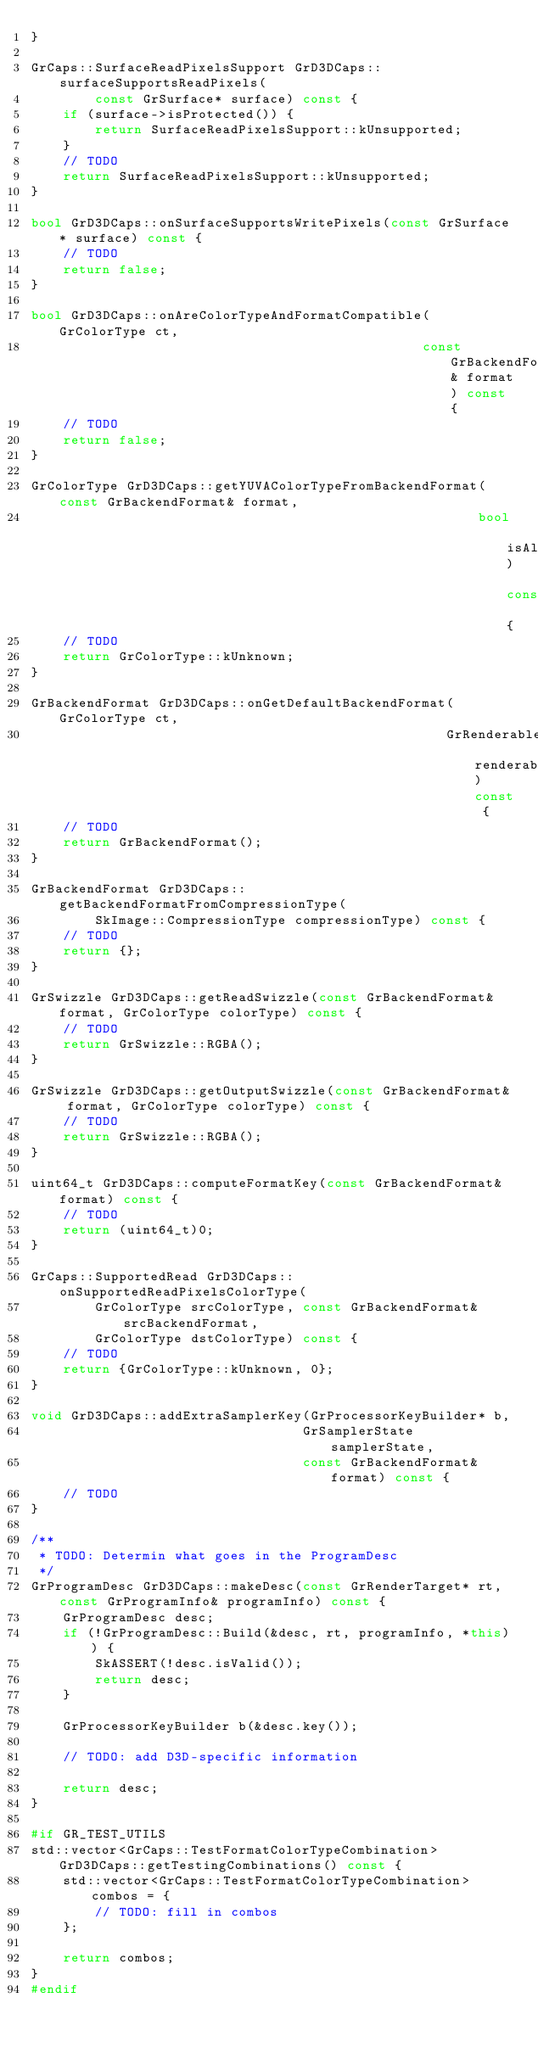Convert code to text. <code><loc_0><loc_0><loc_500><loc_500><_C++_>}

GrCaps::SurfaceReadPixelsSupport GrD3DCaps::surfaceSupportsReadPixels(
        const GrSurface* surface) const {
    if (surface->isProtected()) {
        return SurfaceReadPixelsSupport::kUnsupported;
    }
    // TODO
    return SurfaceReadPixelsSupport::kUnsupported;
}

bool GrD3DCaps::onSurfaceSupportsWritePixels(const GrSurface* surface) const {
    // TODO
    return false;
}

bool GrD3DCaps::onAreColorTypeAndFormatCompatible(GrColorType ct,
                                                 const GrBackendFormat& format) const {
    // TODO
    return false;
}

GrColorType GrD3DCaps::getYUVAColorTypeFromBackendFormat(const GrBackendFormat& format,
                                                        bool isAlphaChannel) const {
    // TODO
    return GrColorType::kUnknown;
}

GrBackendFormat GrD3DCaps::onGetDefaultBackendFormat(GrColorType ct,
                                                    GrRenderable renderable) const {
    // TODO
    return GrBackendFormat();
}

GrBackendFormat GrD3DCaps::getBackendFormatFromCompressionType(
        SkImage::CompressionType compressionType) const {
    // TODO
    return {};
}

GrSwizzle GrD3DCaps::getReadSwizzle(const GrBackendFormat& format, GrColorType colorType) const {
    // TODO
    return GrSwizzle::RGBA();
}

GrSwizzle GrD3DCaps::getOutputSwizzle(const GrBackendFormat& format, GrColorType colorType) const {
    // TODO
    return GrSwizzle::RGBA();
}

uint64_t GrD3DCaps::computeFormatKey(const GrBackendFormat& format) const {
    // TODO
    return (uint64_t)0;
}

GrCaps::SupportedRead GrD3DCaps::onSupportedReadPixelsColorType(
        GrColorType srcColorType, const GrBackendFormat& srcBackendFormat,
        GrColorType dstColorType) const {
    // TODO
    return {GrColorType::kUnknown, 0};
}

void GrD3DCaps::addExtraSamplerKey(GrProcessorKeyBuilder* b,
                                  GrSamplerState samplerState,
                                  const GrBackendFormat& format) const {
    // TODO
}

/**
 * TODO: Determin what goes in the ProgramDesc
 */
GrProgramDesc GrD3DCaps::makeDesc(const GrRenderTarget* rt, const GrProgramInfo& programInfo) const {
    GrProgramDesc desc;
    if (!GrProgramDesc::Build(&desc, rt, programInfo, *this)) {
        SkASSERT(!desc.isValid());
        return desc;
    }

    GrProcessorKeyBuilder b(&desc.key());

    // TODO: add D3D-specific information

    return desc;
}

#if GR_TEST_UTILS
std::vector<GrCaps::TestFormatColorTypeCombination> GrD3DCaps::getTestingCombinations() const {
    std::vector<GrCaps::TestFormatColorTypeCombination> combos = {
        // TODO: fill in combos
    };

    return combos;
}
#endif
</code> 